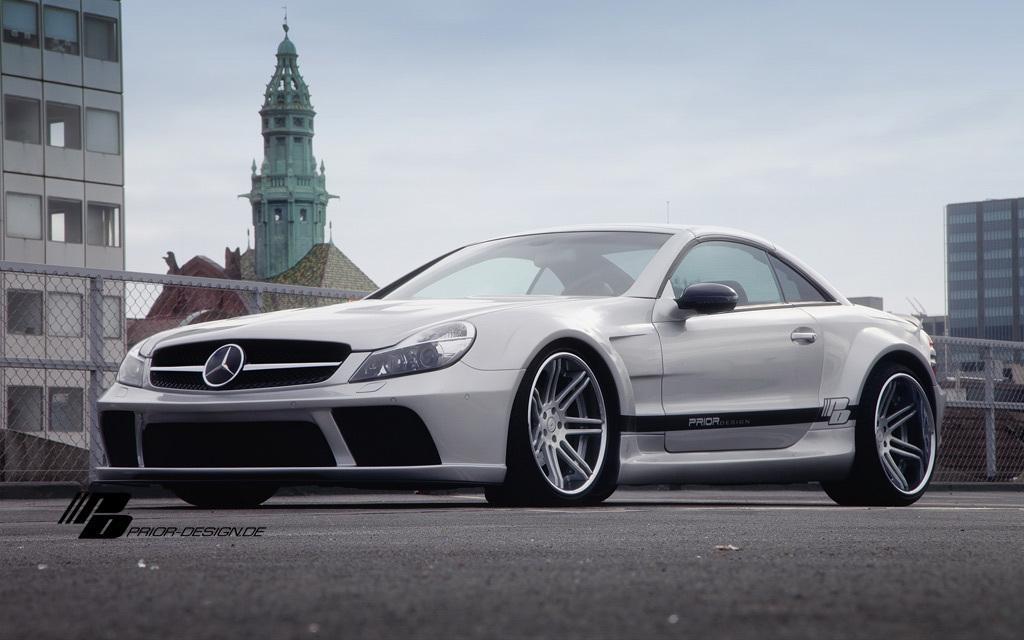Describe this image in one or two sentences. There is a car. In the back there is a mesh fencing. Also there are buildings and sky in the background. And there is a watermark on the image. 